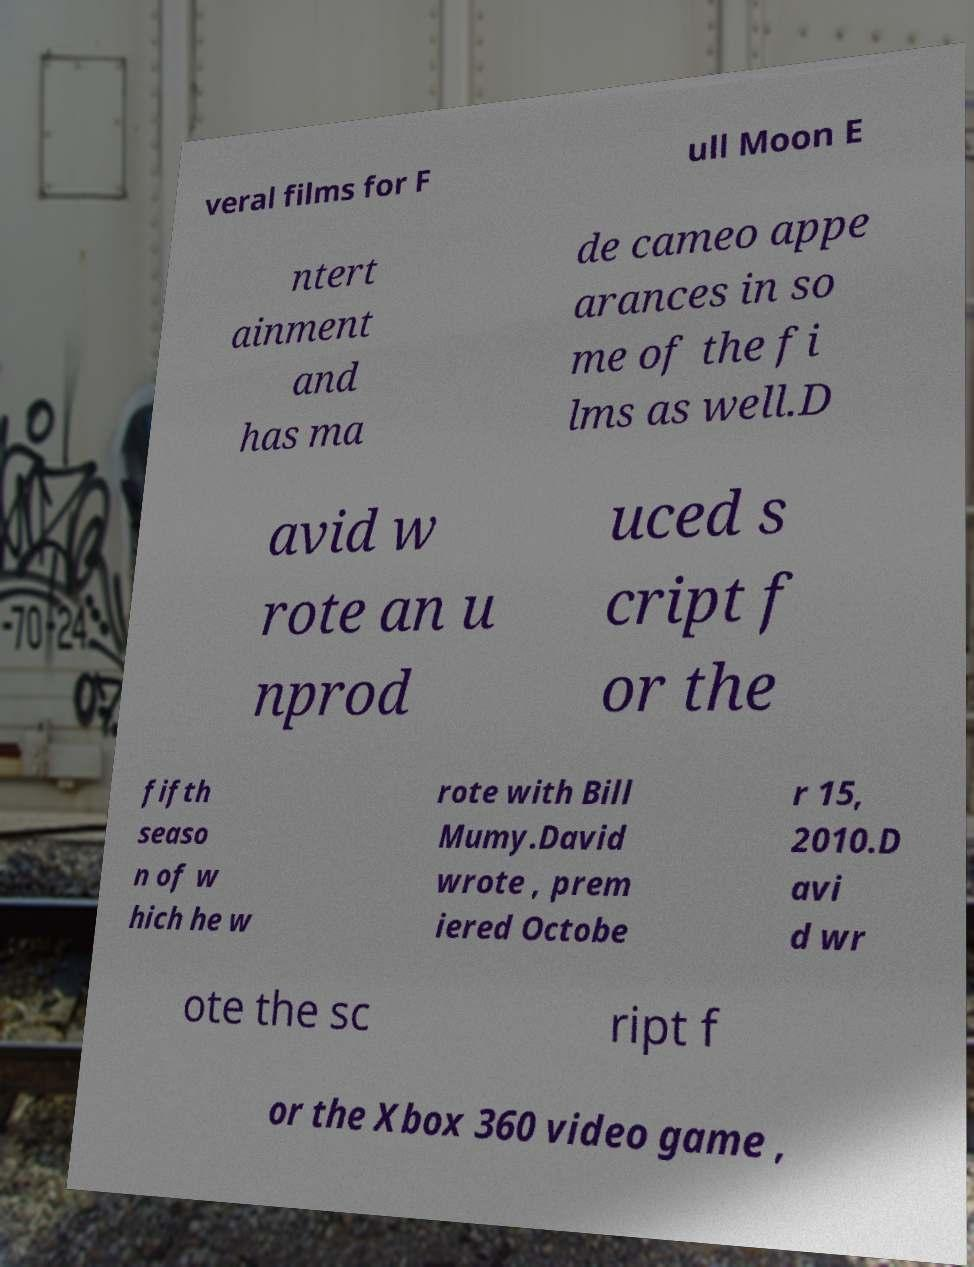Can you accurately transcribe the text from the provided image for me? veral films for F ull Moon E ntert ainment and has ma de cameo appe arances in so me of the fi lms as well.D avid w rote an u nprod uced s cript f or the fifth seaso n of w hich he w rote with Bill Mumy.David wrote , prem iered Octobe r 15, 2010.D avi d wr ote the sc ript f or the Xbox 360 video game , 